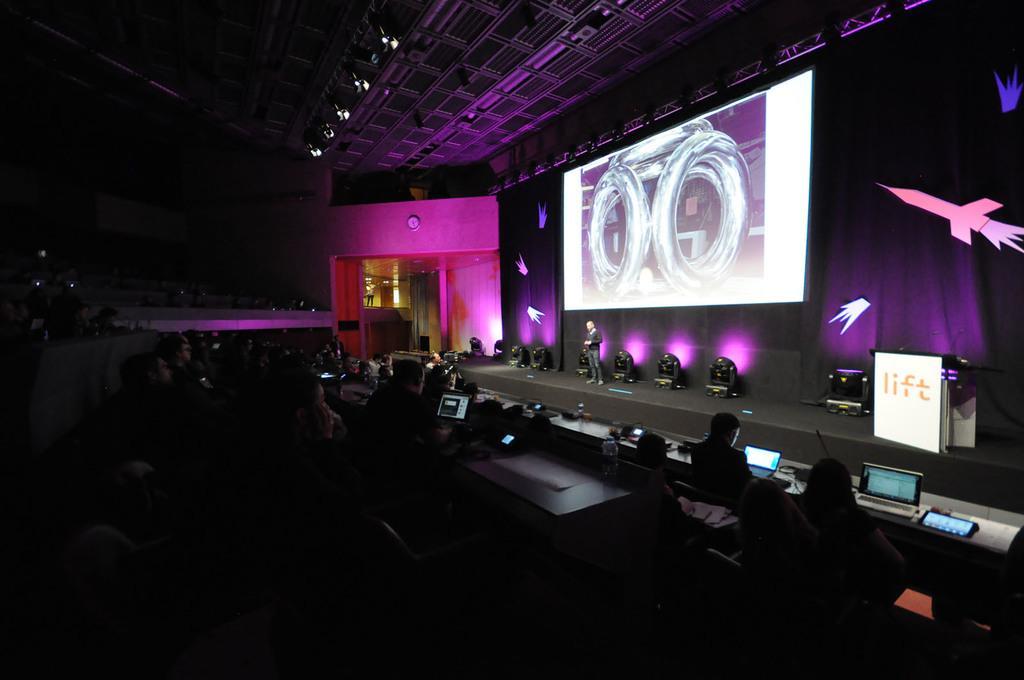Describe this image in one or two sentences. In this image on the left side the image is dark but we can see persons and there are monitors, bottles and objects on the table. In the background a man is standing on the stage, lights, screen, door, clock on the wall and objects on the black color cloth. 